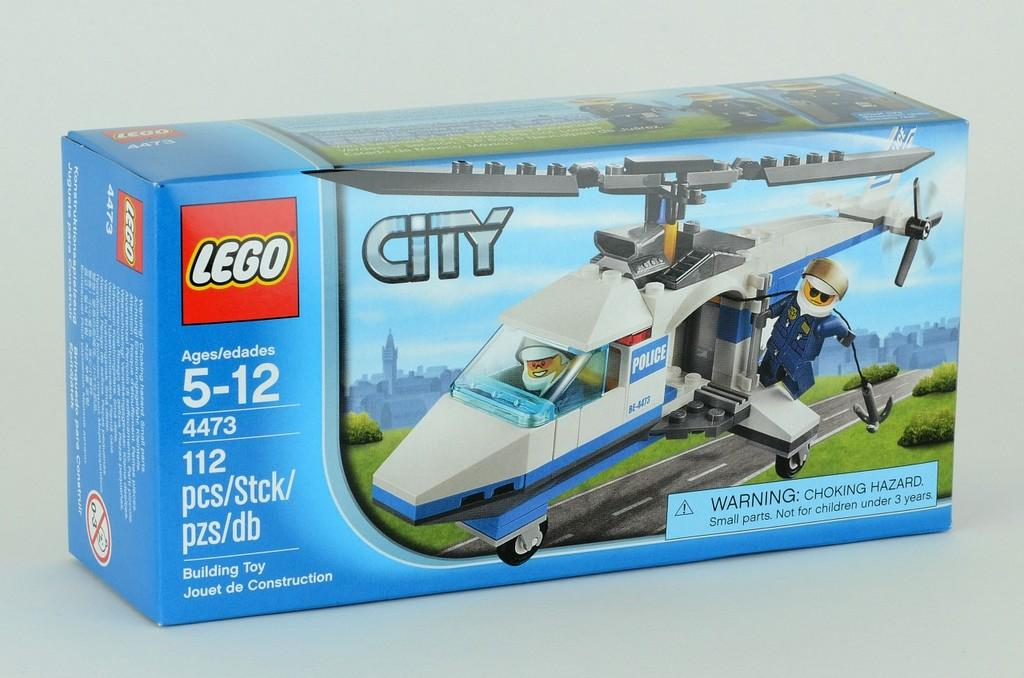<image>
Render a clear and concise summary of the photo. A  small blue Lego box with a helicopter on the front. 